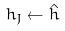Convert formula to latex. <formula><loc_0><loc_0><loc_500><loc_500>h _ { J } \leftarrow \hat { h }</formula> 